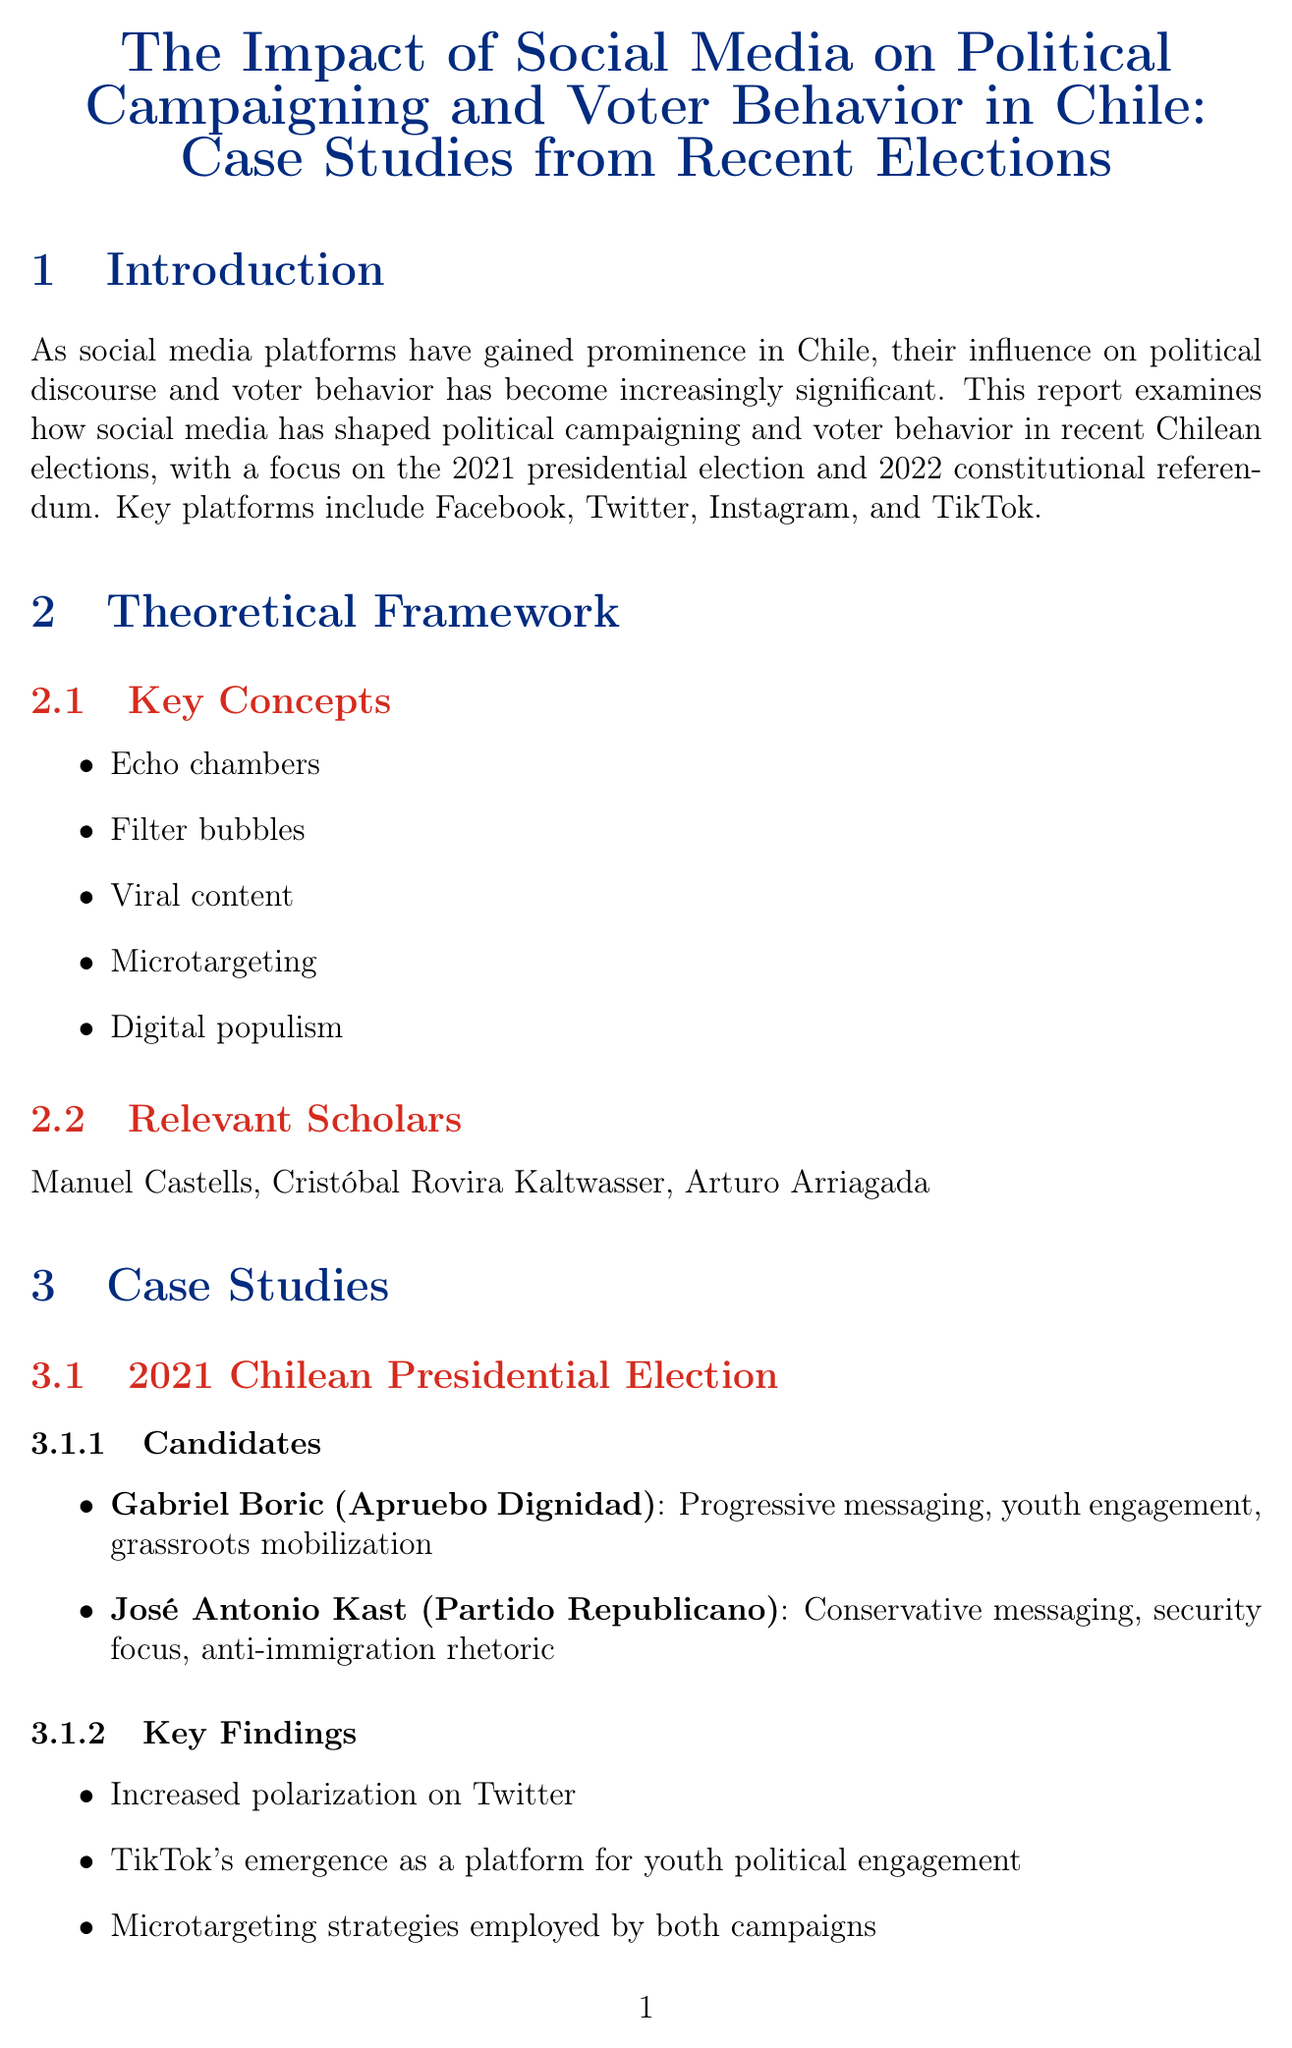What are the key platforms examined in the report? The report cites key platforms that have influenced voter behavior and political campaigning in Chile, which include Facebook, Twitter, Instagram, and TikTok.
Answer: Facebook, Twitter, Instagram, TikTok Who were the candidates in the 2021 Chilean Presidential Election? The document mentions two candidates from the 2021 election, Gabriel Boric and José Antonio Kast, and their respective parties.
Answer: Gabriel Boric, José Antonio Kast What social media strategy did Gabriel Boric use? The report highlights that Gabriel Boric's social media strategy focused on progressive messaging, youth engagement, and grassroots mobilization.
Answer: Progressive messaging, youth engagement, grassroots mobilization What was a key finding from the 2022 Chilean Constitutional Referendum? The report discusses notable findings, including the spread of misinformation on certain platforms during the 2022 referendum.
Answer: Spread of misinformation on WhatsApp and Facebook What is one implication for voters mentioned in the report? The report emphasizes the need for voters to be aware of microtargeting and personalized content as a critical implication of social media influence.
Answer: Awareness of microtargeting and personalized content Which analytical methods were used in the data analysis? The document lists several analytical methods employed in the examination of data, including social network analysis and sentiment analysis.
Answer: Social network analysis, sentiment analysis, content analysis What is mentioned as a challenge for policymakers? The report outlines a challenge for policymakers related to regulating online political advertising and addressing misinformation on social media.
Answer: Challenges in regulating online political advertising and combating misinformation Who are some relevant scholars referenced in the theoretical framework? The report includes scholars who have contributed to the understanding of social media's impact on politics, notably Manuel Castells, Cristóbal Rovira Kaltwasser, and Arturo Arriagada.
Answer: Manuel Castells, Cristóbal Rovira Kaltwasser, Arturo Arriagada 